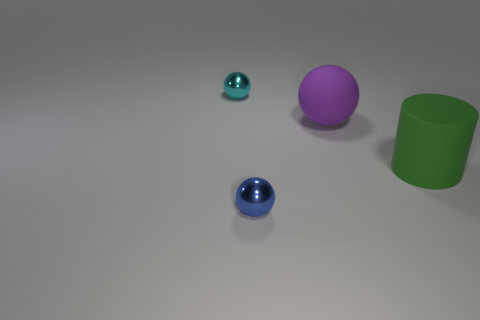Subtract all yellow spheres. Subtract all red blocks. How many spheres are left? 3 Add 1 green objects. How many objects exist? 5 Subtract all spheres. How many objects are left? 1 Subtract all tiny blue shiny objects. Subtract all matte cylinders. How many objects are left? 2 Add 1 small blue objects. How many small blue objects are left? 2 Add 3 small red matte spheres. How many small red matte spheres exist? 3 Subtract 0 brown blocks. How many objects are left? 4 